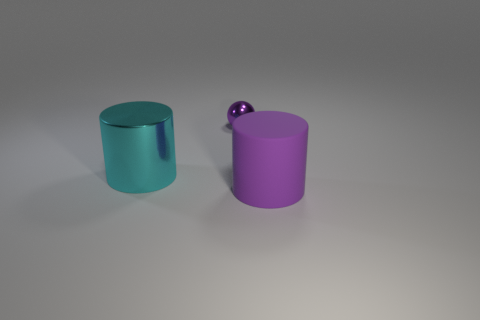What is the shape of the large matte thing that is the same color as the tiny sphere? The large matte object sharing the same color as the tiny sphere is cylindrical in shape. It has a smooth surface with no apparent shine, distinguishing it by its matte texture, and its top is open, providing a hollow space inside. 